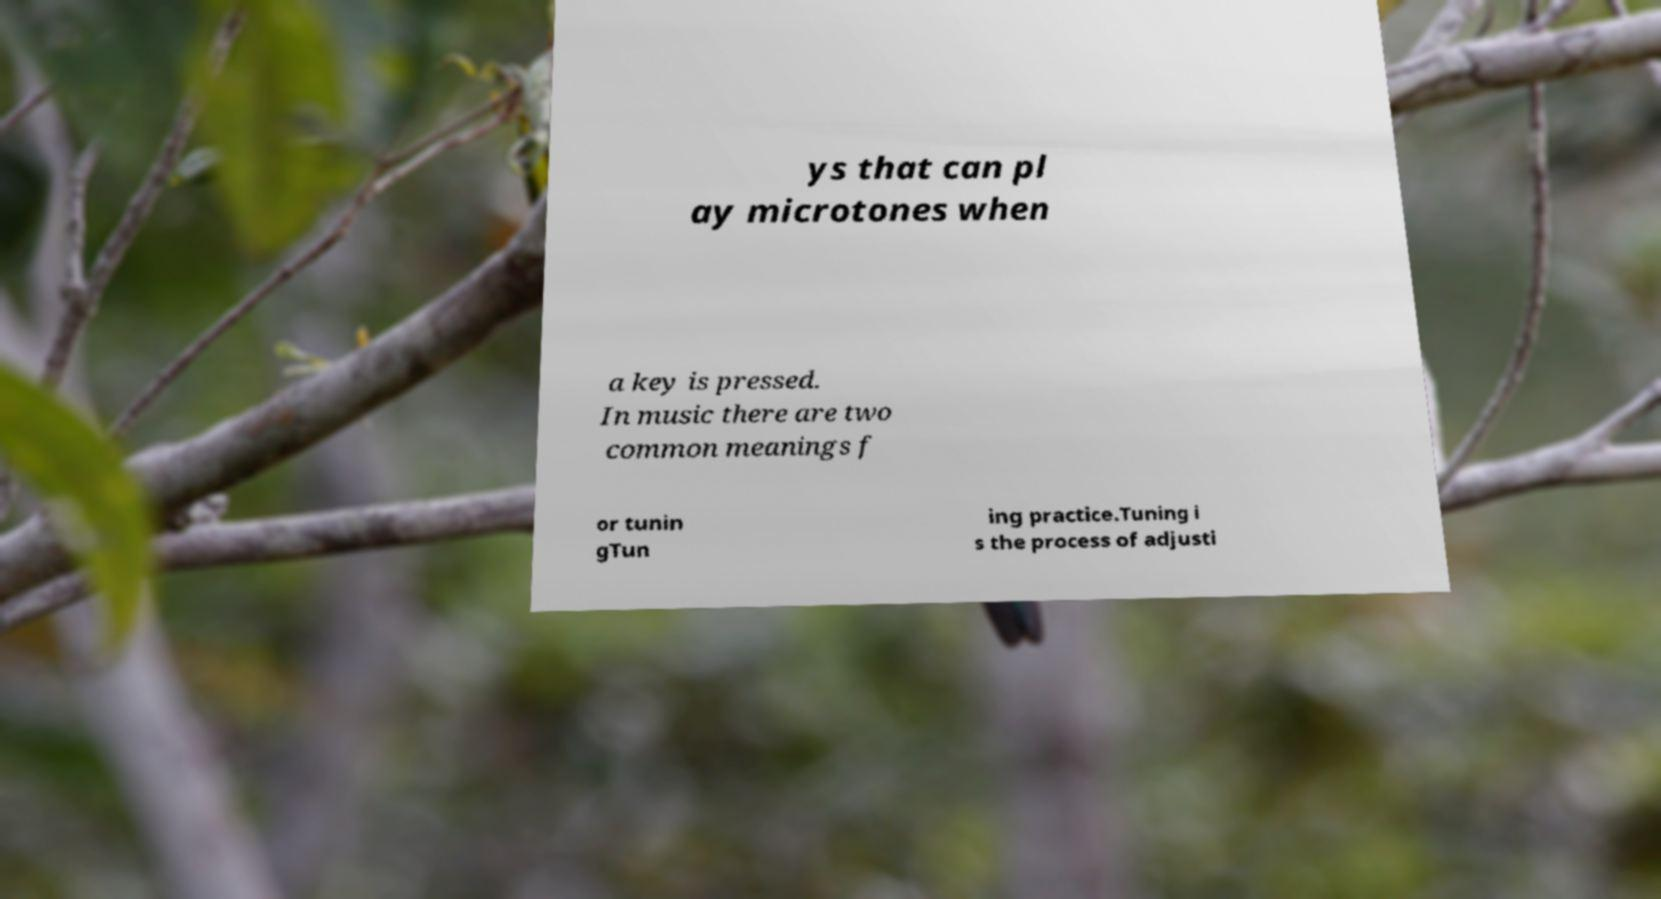Can you read and provide the text displayed in the image?This photo seems to have some interesting text. Can you extract and type it out for me? ys that can pl ay microtones when a key is pressed. In music there are two common meanings f or tunin gTun ing practice.Tuning i s the process of adjusti 